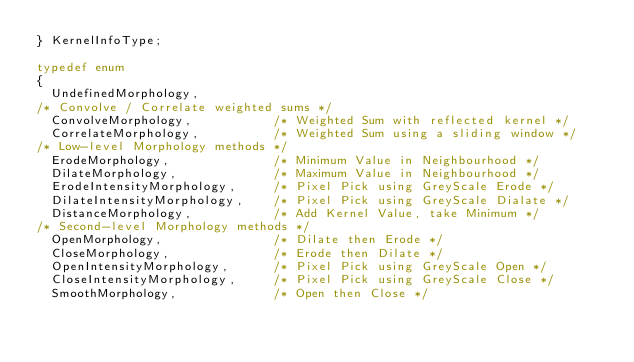<code> <loc_0><loc_0><loc_500><loc_500><_C_>} KernelInfoType;

typedef enum
{
  UndefinedMorphology,
/* Convolve / Correlate weighted sums */
  ConvolveMorphology,           /* Weighted Sum with reflected kernel */
  CorrelateMorphology,          /* Weighted Sum using a sliding window */
/* Low-level Morphology methods */
  ErodeMorphology,              /* Minimum Value in Neighbourhood */
  DilateMorphology,             /* Maximum Value in Neighbourhood */
  ErodeIntensityMorphology,     /* Pixel Pick using GreyScale Erode */
  DilateIntensityMorphology,    /* Pixel Pick using GreyScale Dialate */
  DistanceMorphology,           /* Add Kernel Value, take Minimum */
/* Second-level Morphology methods */
  OpenMorphology,               /* Dilate then Erode */
  CloseMorphology,              /* Erode then Dilate */
  OpenIntensityMorphology,      /* Pixel Pick using GreyScale Open */
  CloseIntensityMorphology,     /* Pixel Pick using GreyScale Close */
  SmoothMorphology,             /* Open then Close */</code> 